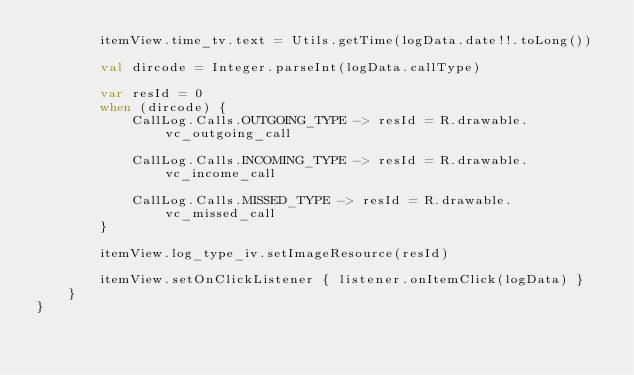<code> <loc_0><loc_0><loc_500><loc_500><_Kotlin_>        itemView.time_tv.text = Utils.getTime(logData.date!!.toLong())

        val dircode = Integer.parseInt(logData.callType)

        var resId = 0
        when (dircode) {
            CallLog.Calls.OUTGOING_TYPE -> resId = R.drawable.vc_outgoing_call

            CallLog.Calls.INCOMING_TYPE -> resId = R.drawable.vc_income_call

            CallLog.Calls.MISSED_TYPE -> resId = R.drawable.vc_missed_call
        }

        itemView.log_type_iv.setImageResource(resId)

        itemView.setOnClickListener { listener.onItemClick(logData) }
    }
}</code> 